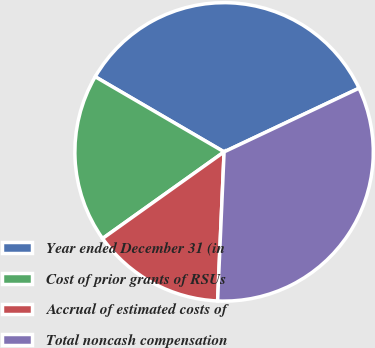Convert chart to OTSL. <chart><loc_0><loc_0><loc_500><loc_500><pie_chart><fcel>Year ended December 31 (in<fcel>Cost of prior grants of RSUs<fcel>Accrual of estimated costs of<fcel>Total noncash compensation<nl><fcel>34.58%<fcel>18.26%<fcel>14.45%<fcel>32.71%<nl></chart> 